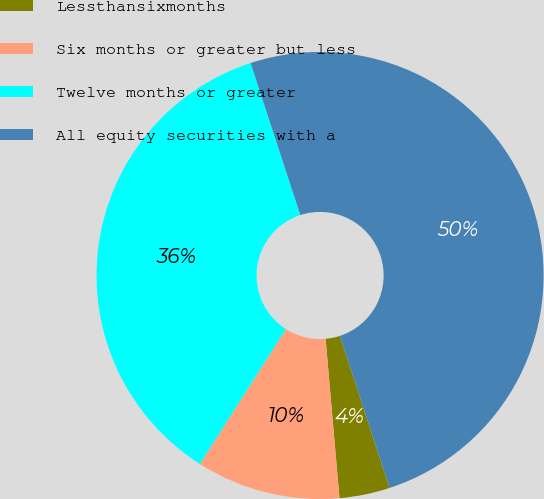Convert chart. <chart><loc_0><loc_0><loc_500><loc_500><pie_chart><fcel>Lessthansixmonths<fcel>Six months or greater but less<fcel>Twelve months or greater<fcel>All equity securities with a<nl><fcel>3.65%<fcel>10.42%<fcel>35.94%<fcel>50.0%<nl></chart> 